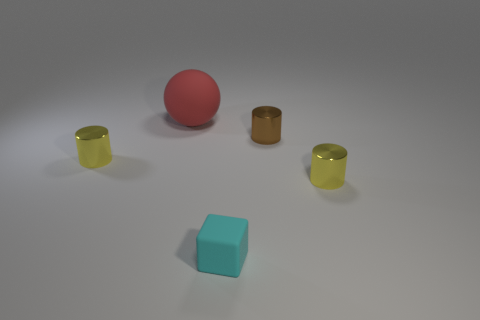Are there any tiny cylinders behind the tiny yellow shiny thing on the left side of the brown object behind the cyan block?
Your answer should be very brief. Yes. Are there fewer cyan rubber objects that are to the left of the rubber sphere than tiny yellow shiny cylinders behind the small matte block?
Ensure brevity in your answer.  Yes. How many other cubes have the same material as the cyan block?
Your answer should be very brief. 0. There is a matte sphere; does it have the same size as the shiny cylinder that is to the left of the block?
Ensure brevity in your answer.  No. There is a yellow metallic cylinder that is in front of the yellow metallic cylinder on the left side of the tiny yellow shiny thing to the right of the red rubber object; what size is it?
Make the answer very short. Small. Is the number of cyan matte blocks that are in front of the tiny cyan rubber object greater than the number of small brown things that are behind the big red thing?
Provide a succinct answer. No. What number of tiny yellow shiny objects are left of the matte thing that is behind the cyan cube?
Make the answer very short. 1. Is there a rubber thing of the same color as the block?
Ensure brevity in your answer.  No. Do the red object and the brown cylinder have the same size?
Offer a very short reply. No. Is the color of the big matte ball the same as the tiny rubber thing?
Your answer should be very brief. No. 